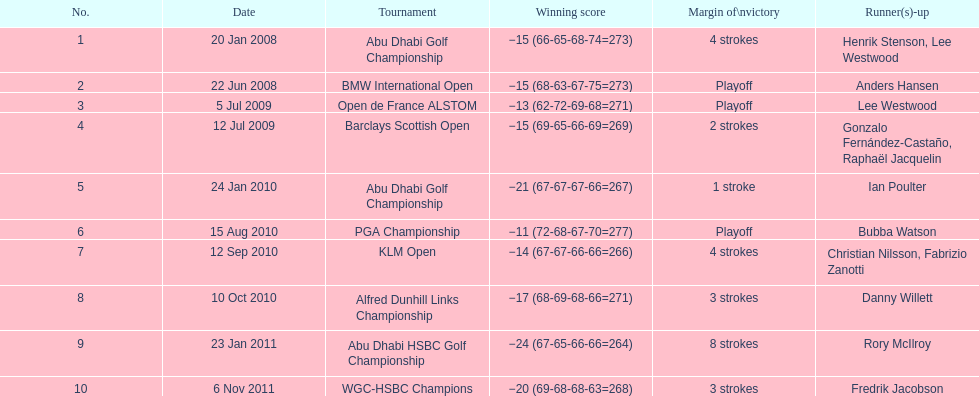Would you be able to parse every entry in this table? {'header': ['No.', 'Date', 'Tournament', 'Winning score', 'Margin of\\nvictory', 'Runner(s)-up'], 'rows': [['1', '20 Jan 2008', 'Abu Dhabi Golf Championship', '−15 (66-65-68-74=273)', '4 strokes', 'Henrik Stenson, Lee Westwood'], ['2', '22 Jun 2008', 'BMW International Open', '−15 (68-63-67-75=273)', 'Playoff', 'Anders Hansen'], ['3', '5 Jul 2009', 'Open de France ALSTOM', '−13 (62-72-69-68=271)', 'Playoff', 'Lee Westwood'], ['4', '12 Jul 2009', 'Barclays Scottish Open', '−15 (69-65-66-69=269)', '2 strokes', 'Gonzalo Fernández-Castaño, Raphaël Jacquelin'], ['5', '24 Jan 2010', 'Abu Dhabi Golf Championship', '−21 (67-67-67-66=267)', '1 stroke', 'Ian Poulter'], ['6', '15 Aug 2010', 'PGA Championship', '−11 (72-68-67-70=277)', 'Playoff', 'Bubba Watson'], ['7', '12 Sep 2010', 'KLM Open', '−14 (67-67-66-66=266)', '4 strokes', 'Christian Nilsson, Fabrizio Zanotti'], ['8', '10 Oct 2010', 'Alfred Dunhill Links Championship', '−17 (68-69-68-66=271)', '3 strokes', 'Danny Willett'], ['9', '23 Jan 2011', 'Abu Dhabi HSBC Golf Championship', '−24 (67-65-66-66=264)', '8 strokes', 'Rory McIlroy'], ['10', '6 Nov 2011', 'WGC-HSBC Champions', '−20 (69-68-68-63=268)', '3 strokes', 'Fredrik Jacobson']]} Who achieved the highest score in the pga championship? Bubba Watson. 